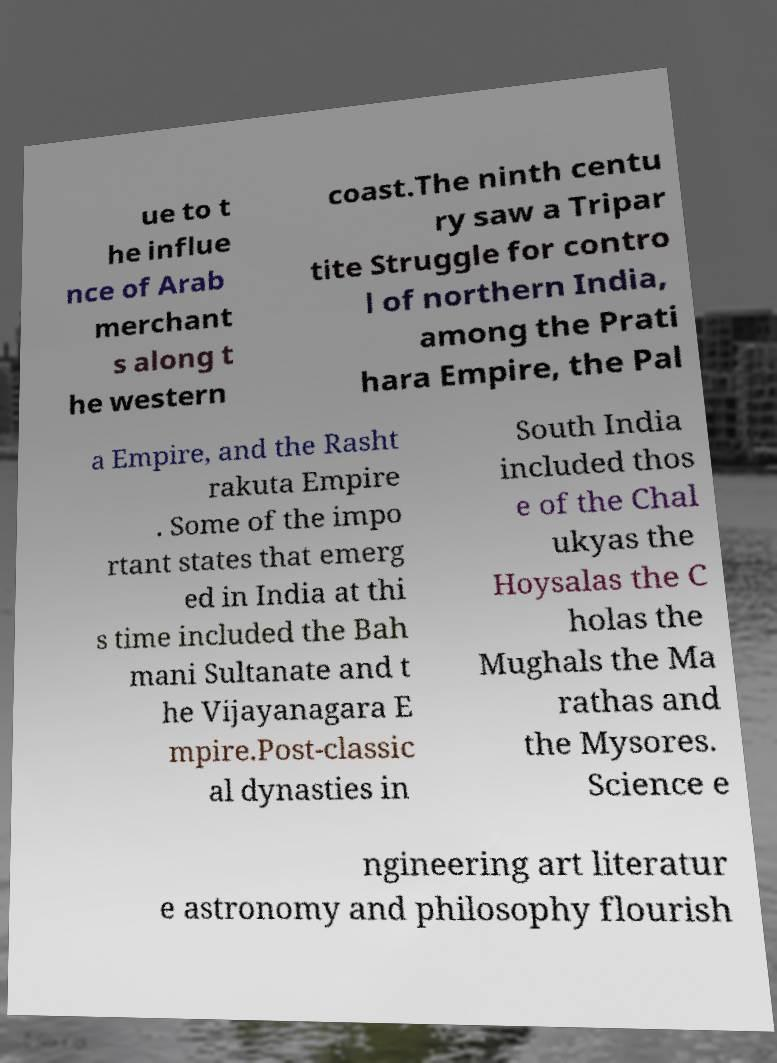For documentation purposes, I need the text within this image transcribed. Could you provide that? ue to t he influe nce of Arab merchant s along t he western coast.The ninth centu ry saw a Tripar tite Struggle for contro l of northern India, among the Prati hara Empire, the Pal a Empire, and the Rasht rakuta Empire . Some of the impo rtant states that emerg ed in India at thi s time included the Bah mani Sultanate and t he Vijayanagara E mpire.Post-classic al dynasties in South India included thos e of the Chal ukyas the Hoysalas the C holas the Mughals the Ma rathas and the Mysores. Science e ngineering art literatur e astronomy and philosophy flourish 